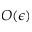<formula> <loc_0><loc_0><loc_500><loc_500>O ( \epsilon )</formula> 